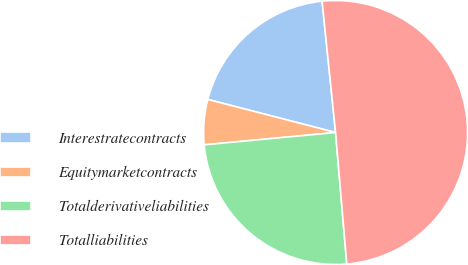Convert chart. <chart><loc_0><loc_0><loc_500><loc_500><pie_chart><fcel>Interestratecontracts<fcel>Equitymarketcontracts<fcel>Totalderivativeliabilities<fcel>Totalliabilities<nl><fcel>19.34%<fcel>5.52%<fcel>24.86%<fcel>50.28%<nl></chart> 